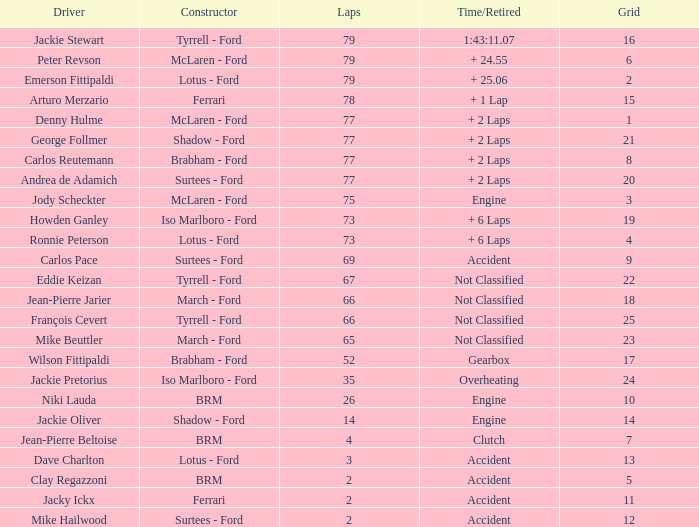How long does it take for less than 35 laps and below 10 grids? Clutch, Accident. 